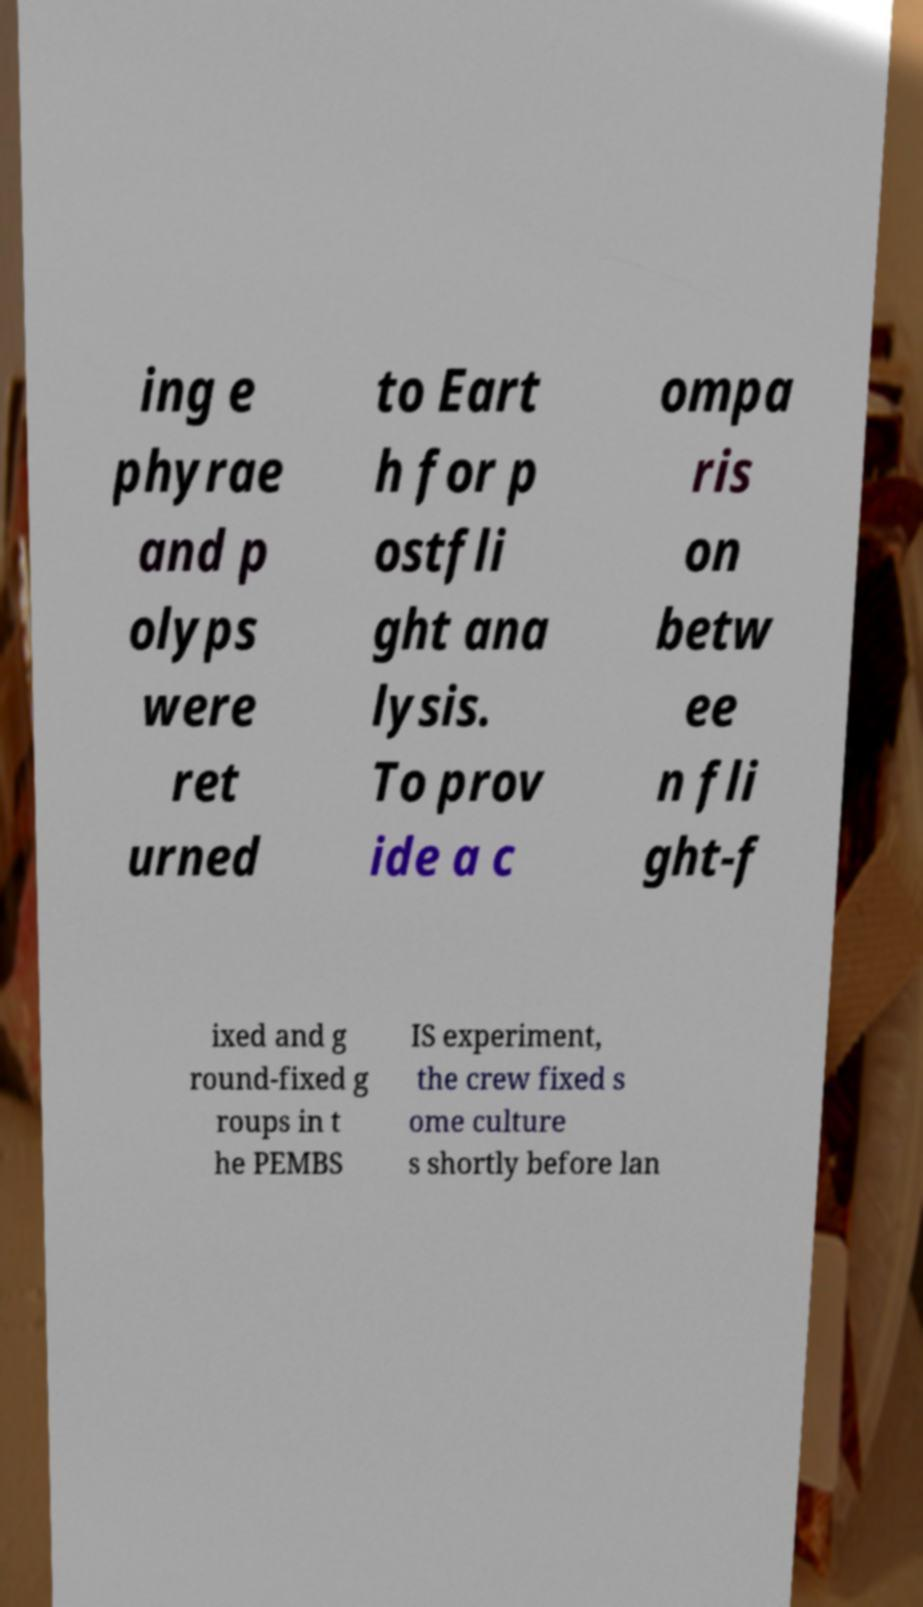What messages or text are displayed in this image? I need them in a readable, typed format. ing e phyrae and p olyps were ret urned to Eart h for p ostfli ght ana lysis. To prov ide a c ompa ris on betw ee n fli ght-f ixed and g round-fixed g roups in t he PEMBS IS experiment, the crew fixed s ome culture s shortly before lan 